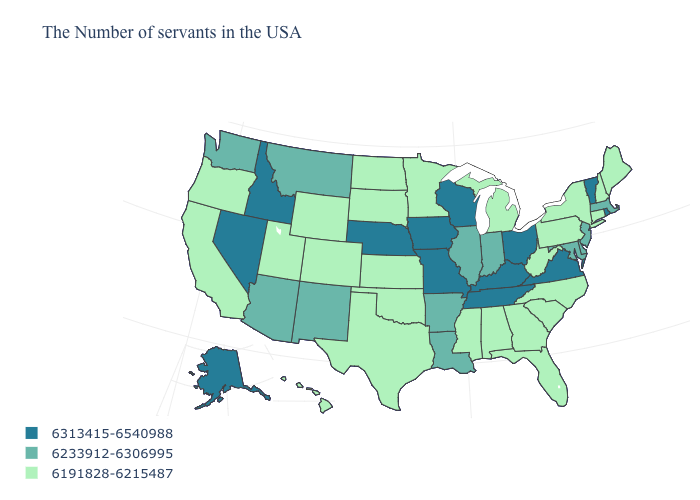Among the states that border Rhode Island , does Connecticut have the highest value?
Be succinct. No. What is the value of New Jersey?
Answer briefly. 6233912-6306995. What is the highest value in the Northeast ?
Keep it brief. 6313415-6540988. What is the value of North Dakota?
Answer briefly. 6191828-6215487. Name the states that have a value in the range 6191828-6215487?
Give a very brief answer. Maine, New Hampshire, Connecticut, New York, Pennsylvania, North Carolina, South Carolina, West Virginia, Florida, Georgia, Michigan, Alabama, Mississippi, Minnesota, Kansas, Oklahoma, Texas, South Dakota, North Dakota, Wyoming, Colorado, Utah, California, Oregon, Hawaii. Name the states that have a value in the range 6191828-6215487?
Quick response, please. Maine, New Hampshire, Connecticut, New York, Pennsylvania, North Carolina, South Carolina, West Virginia, Florida, Georgia, Michigan, Alabama, Mississippi, Minnesota, Kansas, Oklahoma, Texas, South Dakota, North Dakota, Wyoming, Colorado, Utah, California, Oregon, Hawaii. Which states have the lowest value in the USA?
Keep it brief. Maine, New Hampshire, Connecticut, New York, Pennsylvania, North Carolina, South Carolina, West Virginia, Florida, Georgia, Michigan, Alabama, Mississippi, Minnesota, Kansas, Oklahoma, Texas, South Dakota, North Dakota, Wyoming, Colorado, Utah, California, Oregon, Hawaii. Does Illinois have the highest value in the MidWest?
Answer briefly. No. Does Maryland have the lowest value in the USA?
Quick response, please. No. Among the states that border Nebraska , which have the lowest value?
Quick response, please. Kansas, South Dakota, Wyoming, Colorado. Name the states that have a value in the range 6191828-6215487?
Write a very short answer. Maine, New Hampshire, Connecticut, New York, Pennsylvania, North Carolina, South Carolina, West Virginia, Florida, Georgia, Michigan, Alabama, Mississippi, Minnesota, Kansas, Oklahoma, Texas, South Dakota, North Dakota, Wyoming, Colorado, Utah, California, Oregon, Hawaii. What is the value of Oregon?
Concise answer only. 6191828-6215487. Does Idaho have the lowest value in the West?
Concise answer only. No. What is the highest value in the USA?
Quick response, please. 6313415-6540988. Name the states that have a value in the range 6313415-6540988?
Be succinct. Rhode Island, Vermont, Virginia, Ohio, Kentucky, Tennessee, Wisconsin, Missouri, Iowa, Nebraska, Idaho, Nevada, Alaska. 